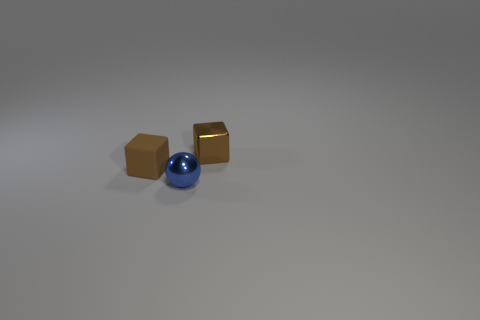Add 2 cubes. How many objects exist? 5 Subtract 1 spheres. How many spheres are left? 0 Subtract all green spheres. Subtract all yellow blocks. How many spheres are left? 1 Subtract 0 red cylinders. How many objects are left? 3 Subtract all spheres. How many objects are left? 2 Subtract all brown matte things. Subtract all tiny brown things. How many objects are left? 0 Add 3 tiny brown matte things. How many tiny brown matte things are left? 4 Add 2 tiny blue cubes. How many tiny blue cubes exist? 2 